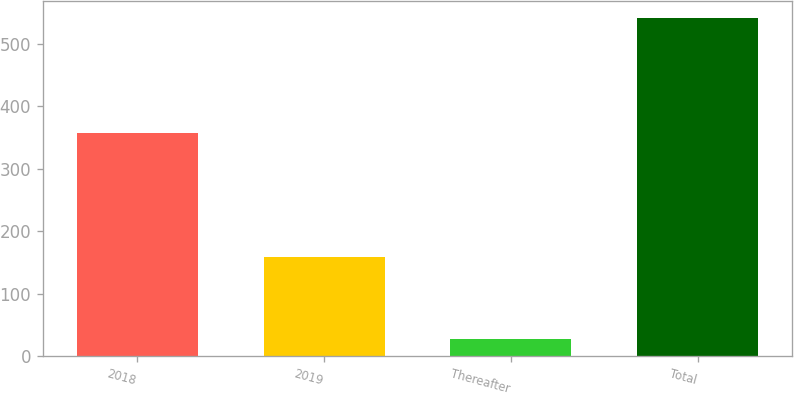<chart> <loc_0><loc_0><loc_500><loc_500><bar_chart><fcel>2018<fcel>2019<fcel>Thereafter<fcel>Total<nl><fcel>357<fcel>158<fcel>27<fcel>542<nl></chart> 